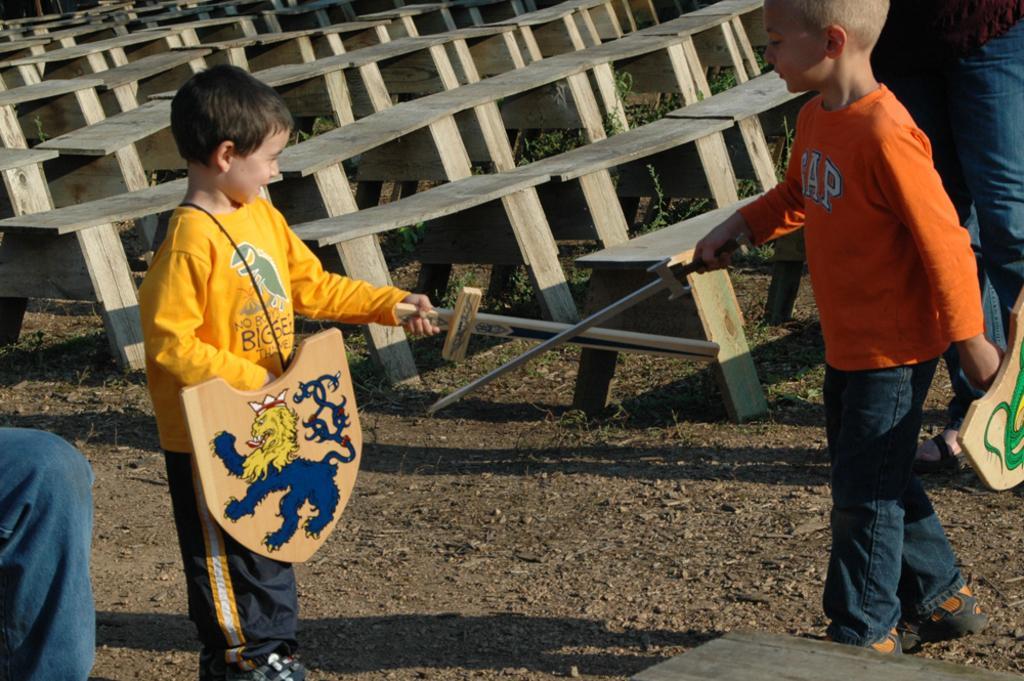Can you describe this image briefly? In this image we can see two boys standing and holding the swords and shields, there are some benches, grass and the legs of the persons. 